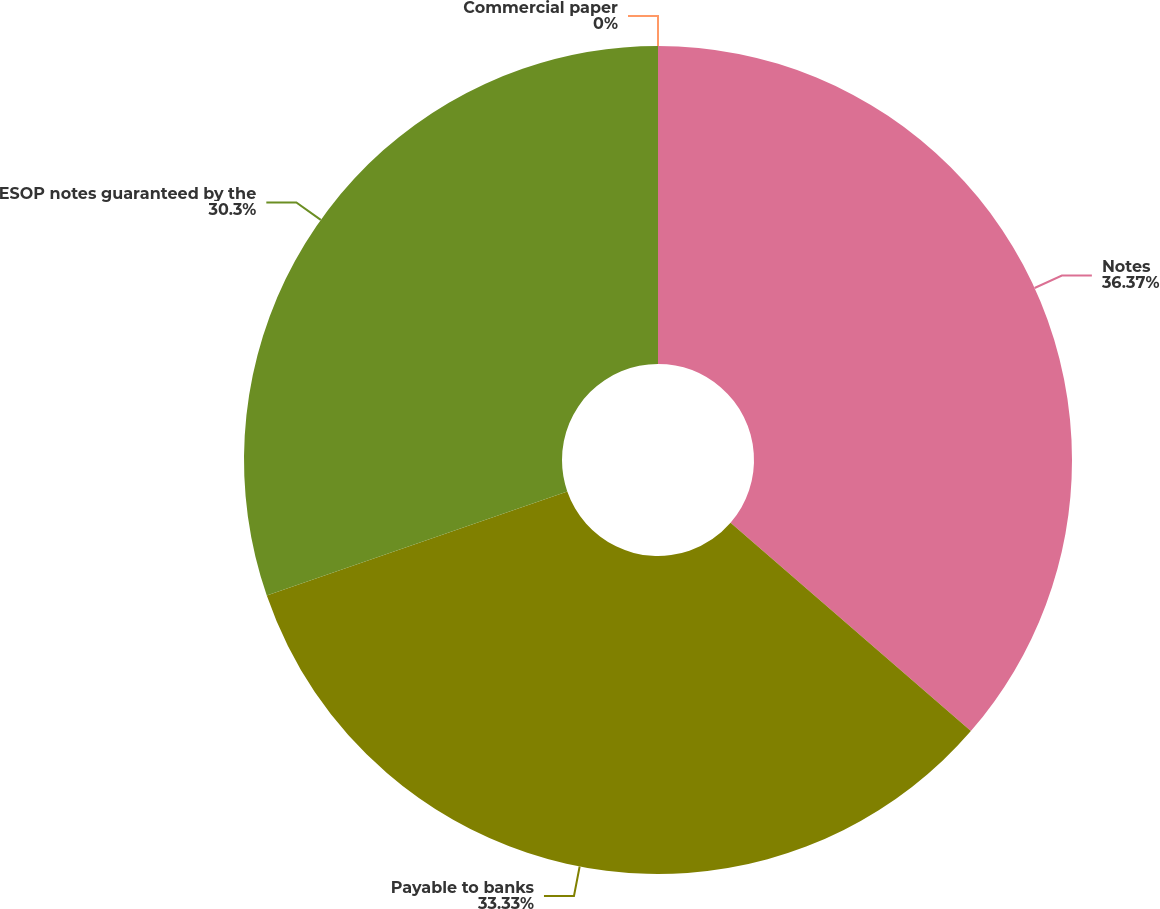Convert chart to OTSL. <chart><loc_0><loc_0><loc_500><loc_500><pie_chart><fcel>Notes<fcel>Payable to banks<fcel>ESOP notes guaranteed by the<fcel>Commercial paper<nl><fcel>36.36%<fcel>33.33%<fcel>30.3%<fcel>0.0%<nl></chart> 